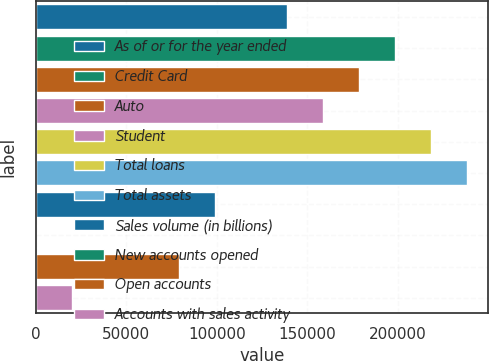Convert chart to OTSL. <chart><loc_0><loc_0><loc_500><loc_500><bar_chart><fcel>As of or for the year ended<fcel>Credit Card<fcel>Auto<fcel>Student<fcel>Total loans<fcel>Total assets<fcel>Sales volume (in billions)<fcel>New accounts opened<fcel>Open accounts<fcel>Accounts with sales activity<nl><fcel>138788<fcel>198265<fcel>178439<fcel>158613<fcel>218091<fcel>237917<fcel>99136.1<fcel>7.3<fcel>79310.4<fcel>19833.1<nl></chart> 